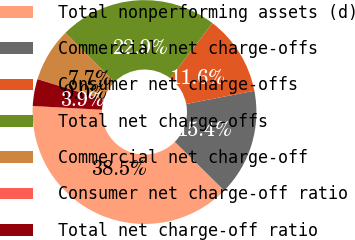Convert chart. <chart><loc_0><loc_0><loc_500><loc_500><pie_chart><fcel>Total nonperforming assets (d)<fcel>Commercial net charge-offs<fcel>Consumer net charge-offs<fcel>Total net charge-offs<fcel>Commercial net charge-off<fcel>Consumer net charge-off ratio<fcel>Total net charge-off ratio<nl><fcel>38.49%<fcel>15.42%<fcel>11.57%<fcel>22.88%<fcel>7.73%<fcel>0.03%<fcel>3.88%<nl></chart> 